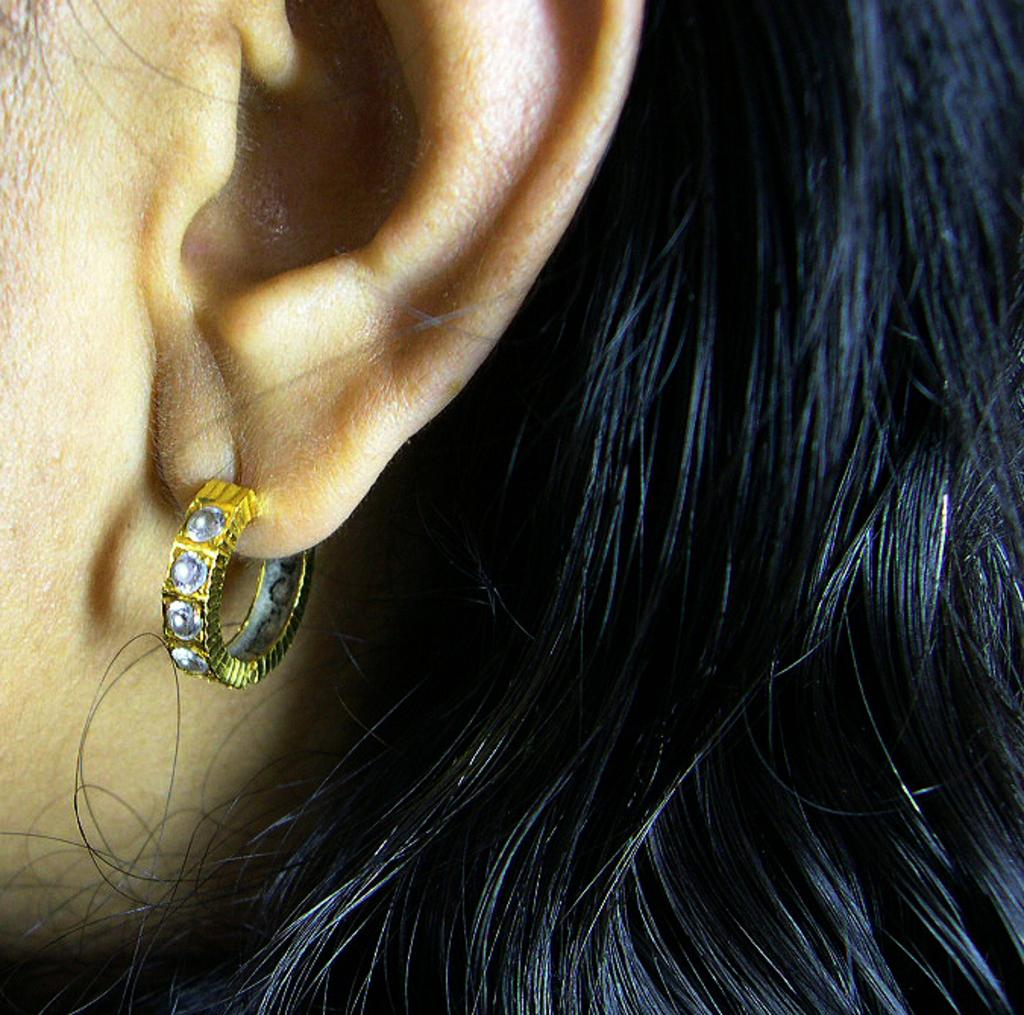What part of a woman's body is the main subject of the image? There is a woman's ear in the image. What is the color of the woman's earring? The woman's earring is golden. What is the color of the woman's hair? The woman has black hair. How many deer can be seen grazing on the farm in the image? There are no deer or farms present in the image; it features a woman's ear with a golden earring and black hair. Can you tell me how many ants are crawling on the woman's ear in the image? There are no ants visible on the woman's ear in the image. 